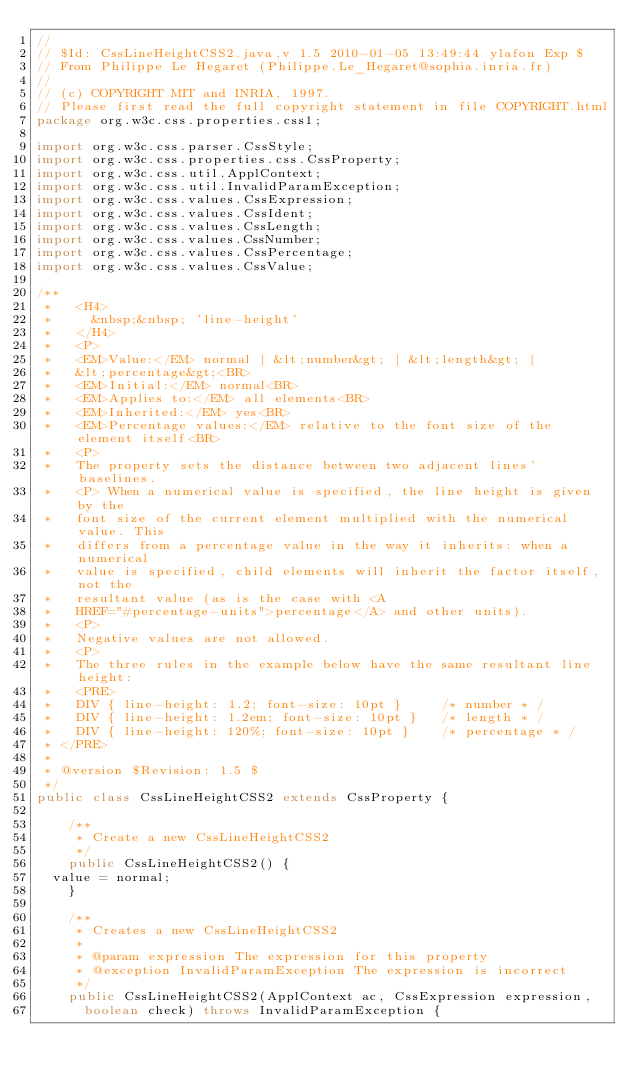Convert code to text. <code><loc_0><loc_0><loc_500><loc_500><_Java_>//
// $Id: CssLineHeightCSS2.java,v 1.5 2010-01-05 13:49:44 ylafon Exp $
// From Philippe Le Hegaret (Philippe.Le_Hegaret@sophia.inria.fr)
//
// (c) COPYRIGHT MIT and INRIA, 1997.
// Please first read the full copyright statement in file COPYRIGHT.html
package org.w3c.css.properties.css1;

import org.w3c.css.parser.CssStyle;
import org.w3c.css.properties.css.CssProperty;
import org.w3c.css.util.ApplContext;
import org.w3c.css.util.InvalidParamException;
import org.w3c.css.values.CssExpression;
import org.w3c.css.values.CssIdent;
import org.w3c.css.values.CssLength;
import org.w3c.css.values.CssNumber;
import org.w3c.css.values.CssPercentage;
import org.w3c.css.values.CssValue;

/**
 *   <H4>
 *     &nbsp;&nbsp; 'line-height'
 *   </H4>
 *   <P>
 *   <EM>Value:</EM> normal | &lt;number&gt; | &lt;length&gt; |
 *   &lt;percentage&gt;<BR>
 *   <EM>Initial:</EM> normal<BR>
 *   <EM>Applies to:</EM> all elements<BR>
 *   <EM>Inherited:</EM> yes<BR>
 *   <EM>Percentage values:</EM> relative to the font size of the element itself<BR>
 *   <P>
 *   The property sets the distance between two adjacent lines' baselines.
 *   <P> When a numerical value is specified, the line height is given by the
 *   font size of the current element multiplied with the numerical value. This
 *   differs from a percentage value in the way it inherits: when a numerical
 *   value is specified, child elements will inherit the factor itself, not the
 *   resultant value (as is the case with <A
 *   HREF="#percentage-units">percentage</A> and other units).
 *   <P>
 *   Negative values are not allowed.
 *   <P>
 *   The three rules in the example below have the same resultant line height:
 *   <PRE>
 *   DIV { line-height: 1.2; font-size: 10pt }     /* number * /
 *   DIV { line-height: 1.2em; font-size: 10pt }   /* length * /
 *   DIV { line-height: 120%; font-size: 10pt }    /* percentage * /
 * </PRE>
 *
 * @version $Revision: 1.5 $
 */
public class CssLineHeightCSS2 extends CssProperty {

    /**
     * Create a new CssLineHeightCSS2
     */
    public CssLineHeightCSS2() {
	value = normal;
    }

    /**
     * Creates a new CssLineHeightCSS2
     *
     * @param expression The expression for this property
     * @exception InvalidParamException The expression is incorrect
     */
    public CssLineHeightCSS2(ApplContext ac, CssExpression expression,
	    boolean check) throws InvalidParamException {
</code> 